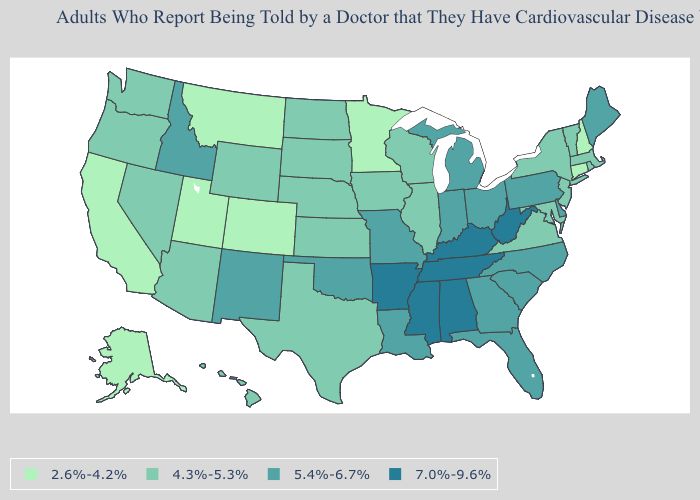Among the states that border Rhode Island , does Massachusetts have the lowest value?
Be succinct. No. What is the value of Nevada?
Keep it brief. 4.3%-5.3%. What is the value of Nevada?
Be succinct. 4.3%-5.3%. What is the lowest value in the USA?
Keep it brief. 2.6%-4.2%. What is the highest value in the USA?
Give a very brief answer. 7.0%-9.6%. Name the states that have a value in the range 5.4%-6.7%?
Answer briefly. Delaware, Florida, Georgia, Idaho, Indiana, Louisiana, Maine, Michigan, Missouri, New Mexico, North Carolina, Ohio, Oklahoma, Pennsylvania, South Carolina. Name the states that have a value in the range 2.6%-4.2%?
Quick response, please. Alaska, California, Colorado, Connecticut, Minnesota, Montana, New Hampshire, Utah. Does Kentucky have the highest value in the USA?
Write a very short answer. Yes. What is the highest value in states that border Nevada?
Quick response, please. 5.4%-6.7%. Does Mississippi have the same value as Kansas?
Write a very short answer. No. What is the value of Connecticut?
Keep it brief. 2.6%-4.2%. Name the states that have a value in the range 4.3%-5.3%?
Give a very brief answer. Arizona, Hawaii, Illinois, Iowa, Kansas, Maryland, Massachusetts, Nebraska, Nevada, New Jersey, New York, North Dakota, Oregon, Rhode Island, South Dakota, Texas, Vermont, Virginia, Washington, Wisconsin, Wyoming. What is the value of Indiana?
Concise answer only. 5.4%-6.7%. Which states have the lowest value in the West?
Quick response, please. Alaska, California, Colorado, Montana, Utah. Among the states that border Oklahoma , does Arkansas have the highest value?
Concise answer only. Yes. 